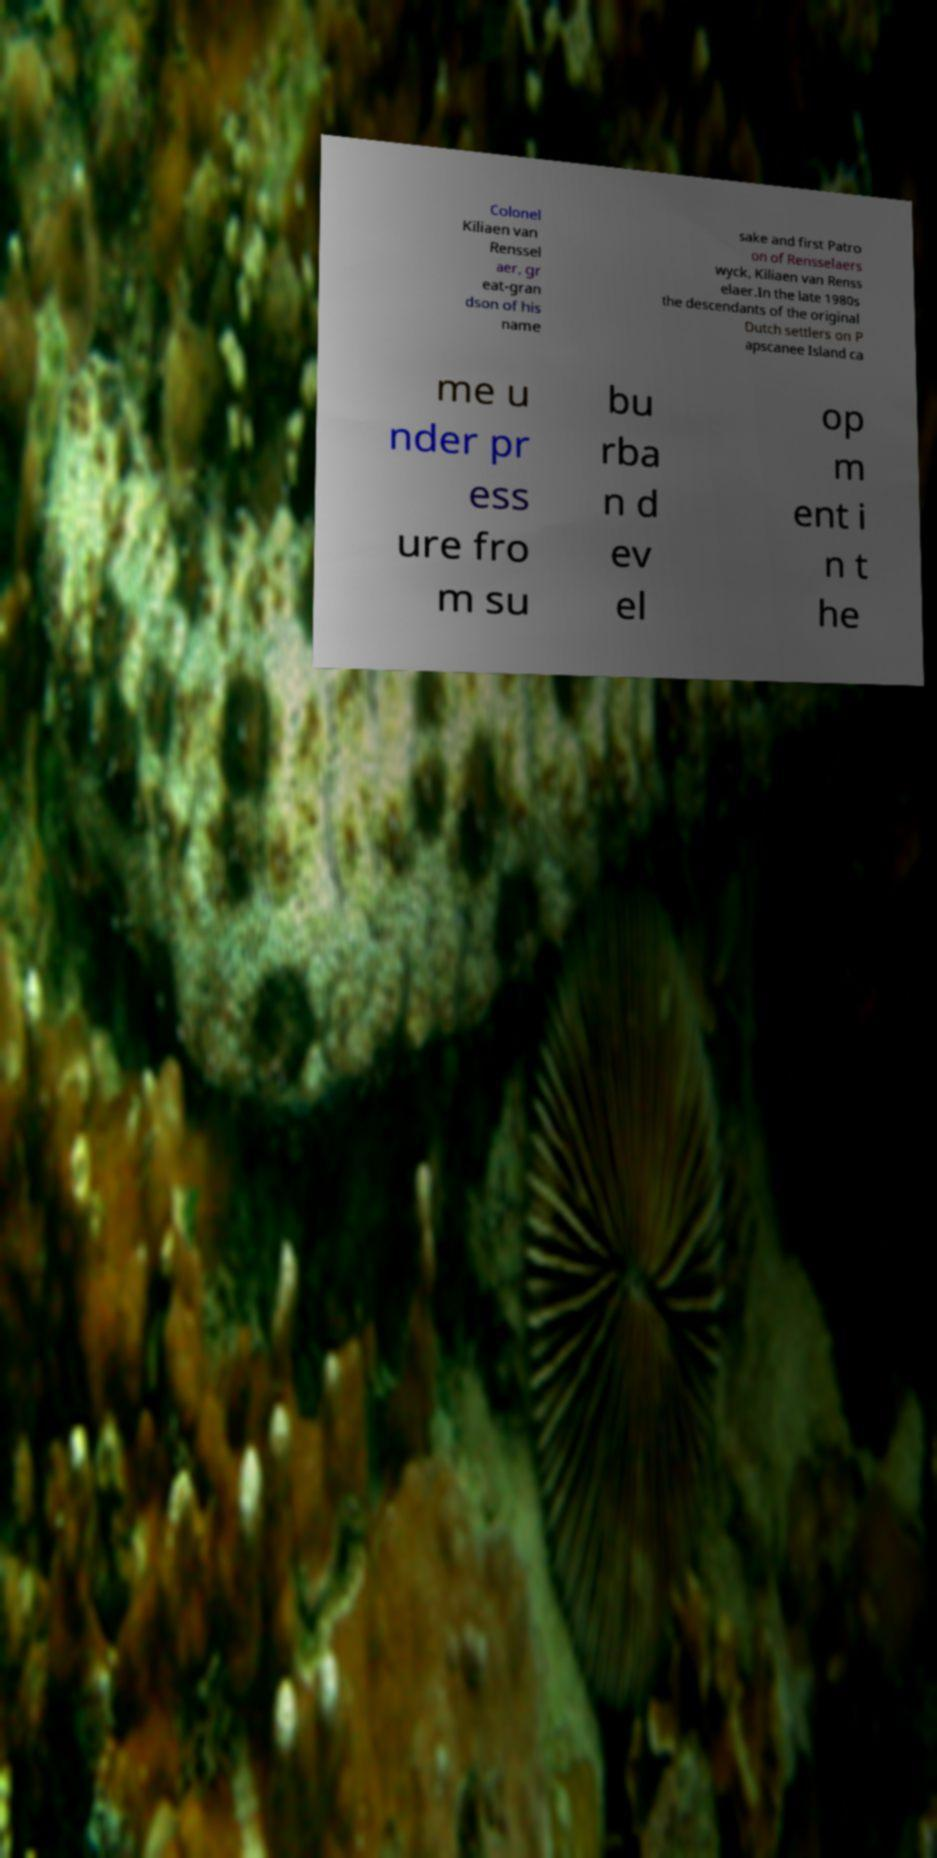For documentation purposes, I need the text within this image transcribed. Could you provide that? Colonel Kiliaen van Renssel aer, gr eat-gran dson of his name sake and first Patro on of Rensselaers wyck, Kiliaen van Renss elaer.In the late 1980s the descendants of the original Dutch settlers on P apscanee Island ca me u nder pr ess ure fro m su bu rba n d ev el op m ent i n t he 